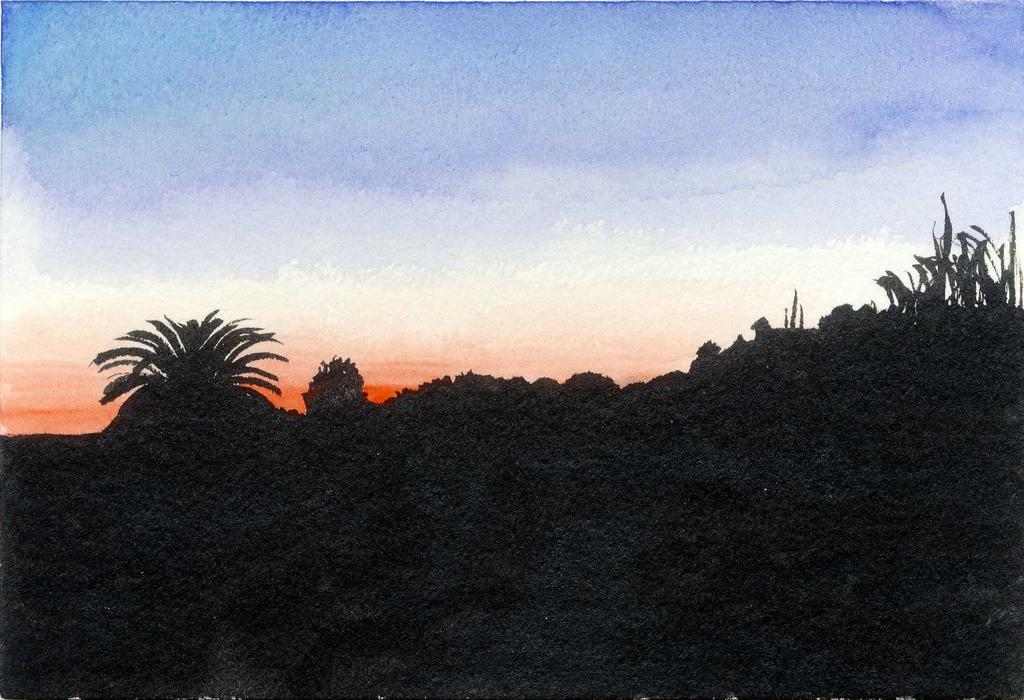What type of artwork is depicted in the image? The image appears to be a painting. What type of vegetation can be seen in the image? There are trees and plants in the image. What is visible at the top of the image? The sky is visible at the top of the image. Where is the harbor located in the image? There is no harbor present in the image. What advice does the mom give in the image? There is no mom or any dialogue present in the image. 